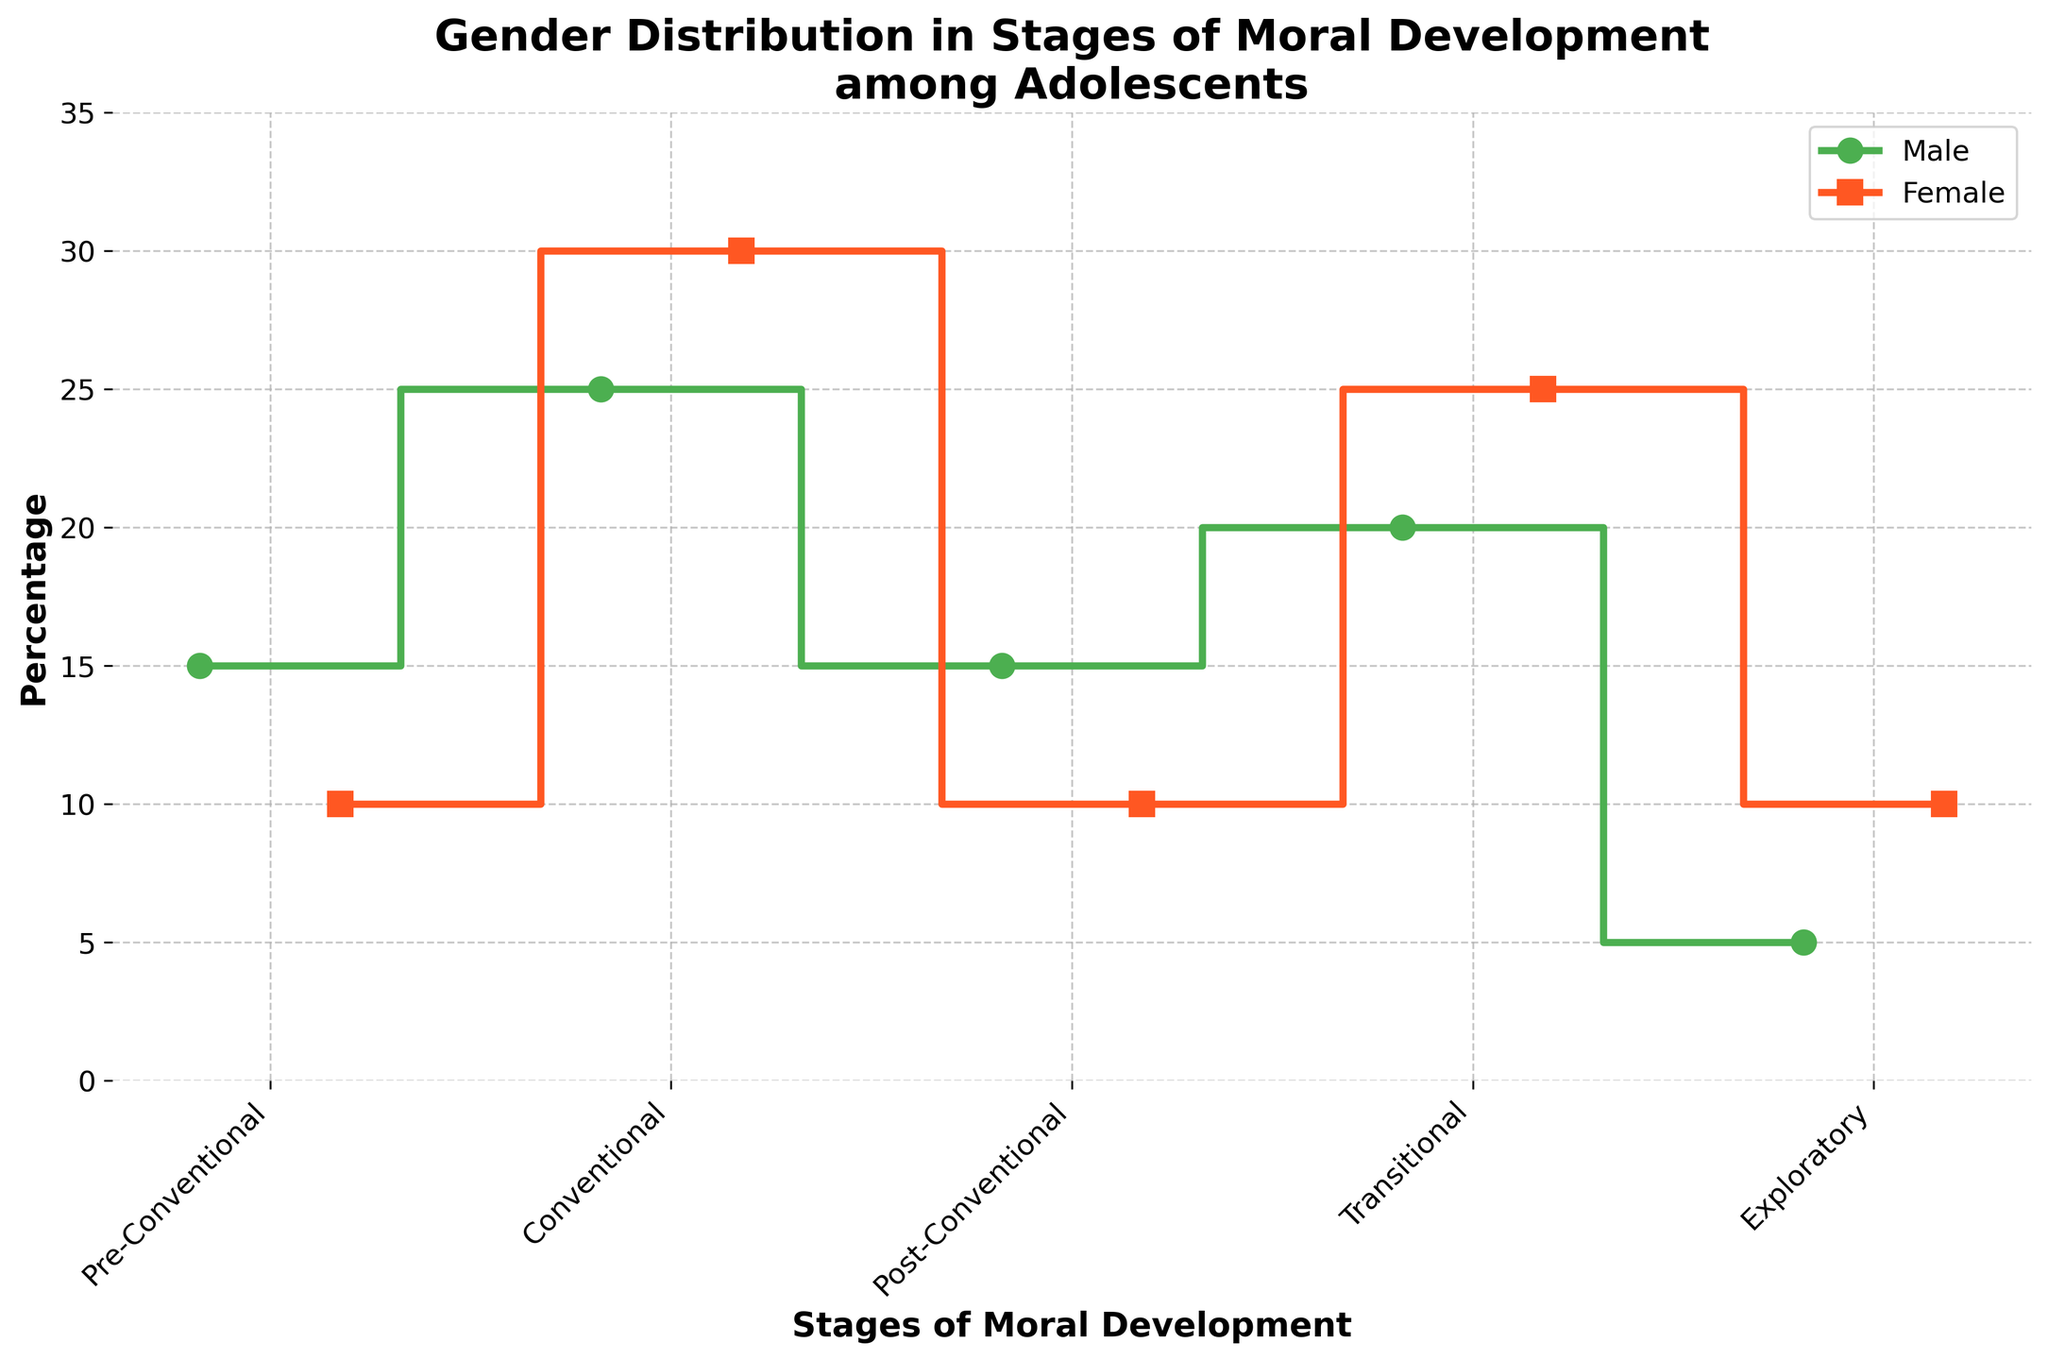What's the title of the figure? The title of the figure is typically located at the top of the plot. It gives an overview of what the figure represents. By looking at the top, we can read the title clearly.
Answer: Gender Distribution in Stages of Moral Development among Adolescents What color represents the male gender in the plot? The color representing each gender can be identified by looking at the plot legend. The male gender is represented by the green line in the legend.
Answer: Green How many stages of moral development are shown for both genders? The stages of moral development are shown on the x-axis. By counting the unique stage labels on the x-axis, we determine the number of stages.
Answer: 5 What's the percentage of females in the Exploratory stage of moral development? To find the percentage, refer to the point on the x-axis labeled "Exploratory" and look at the value for the female line (red triangle).
Answer: 10% In which stage do males and females have equal percentages? By comparing the lines for males and females across the stages, we see that the percentages match at the Post-Conventional stage.
Answer: Post-Conventional What is the difference between the male and female percentages in the Conventional stage? Locate the Conventional stage on the x-axis and read the percentages for both genders. Subtract the female percentage (30%) from the male percentage (25%).
Answer: 5% Which gender has a higher percentage in the Transitional stage, and by how much? Compare the positions of the dots at the Transitional stage. The male percentage is 20% while the female percentage is 25%. The difference is calculated by subtracting the male percentage from the female percentage.
Answer: Female, by 5% Which stage has the highest percentage for females, and what is that percentage? Examine the female (red) line and find its peak value across the stages. The highest value for females is in the Conventional stage.
Answer: Conventional, 30% What is the average percentage of males across all stages of moral development? Sum up the percentages for males (15 + 25 + 15 + 20 + 5) and divide by the number of stages, which is 5. The calculation is (15 + 25 + 15 + 20 + 5) / 5 = 16.
Answer: 16 In which stage do the percentages for both genders show the lowest values? Identify the smallest value points for both lines. Both reach their lowest at the Exploratory stage, with males at 5% and females at 10%.
Answer: Exploratory 